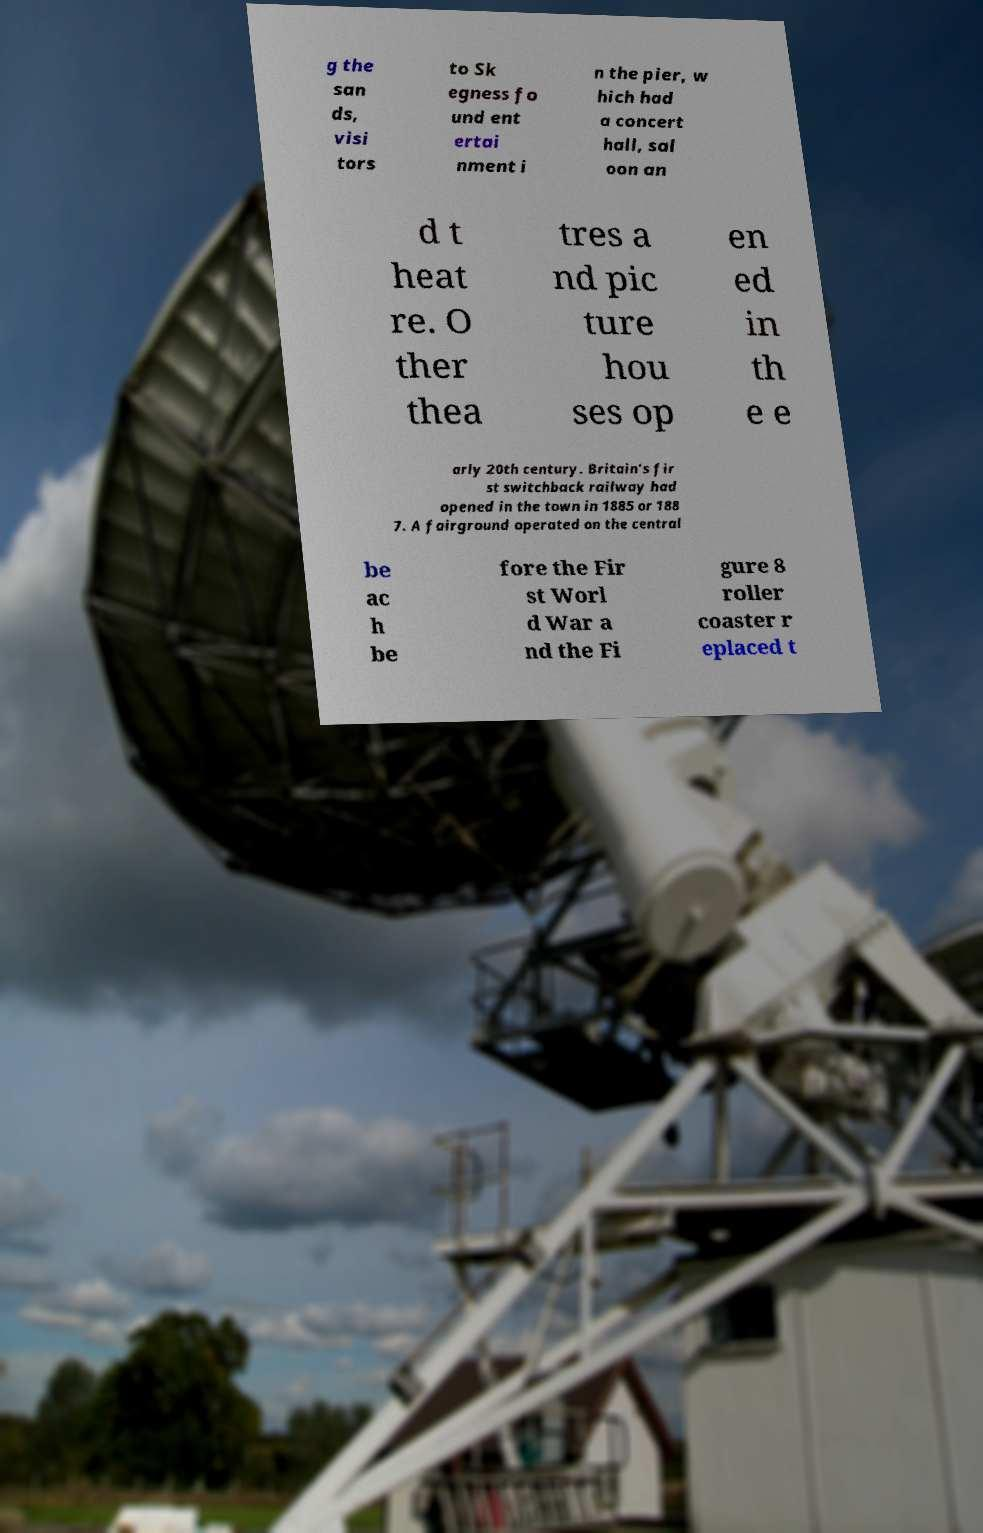Could you extract and type out the text from this image? g the san ds, visi tors to Sk egness fo und ent ertai nment i n the pier, w hich had a concert hall, sal oon an d t heat re. O ther thea tres a nd pic ture hou ses op en ed in th e e arly 20th century. Britain's fir st switchback railway had opened in the town in 1885 or 188 7. A fairground operated on the central be ac h be fore the Fir st Worl d War a nd the Fi gure 8 roller coaster r eplaced t 